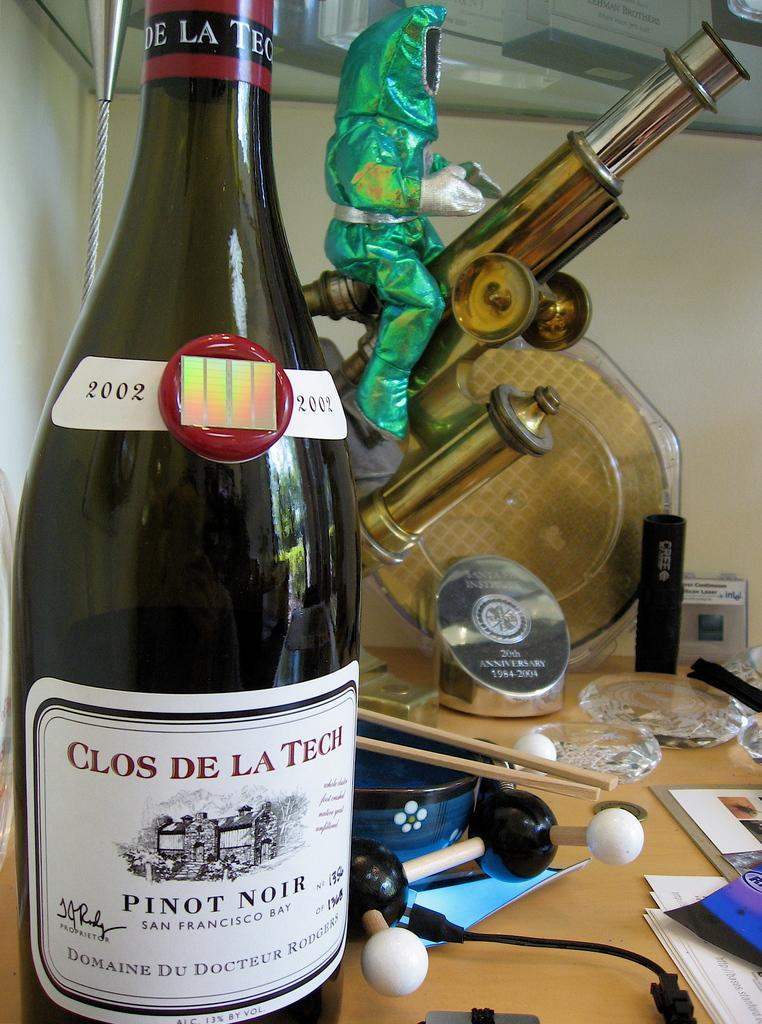<image>
Offer a succinct explanation of the picture presented. A bottle of Clos De La Tech pinot noir wine sitting on a cuttered table. 